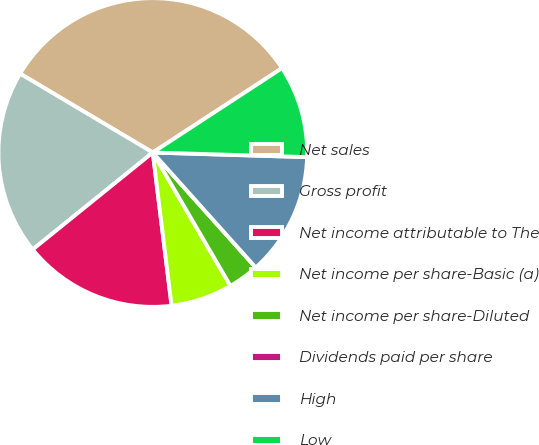Convert chart. <chart><loc_0><loc_0><loc_500><loc_500><pie_chart><fcel>Net sales<fcel>Gross profit<fcel>Net income attributable to The<fcel>Net income per share-Basic (a)<fcel>Net income per share-Diluted<fcel>Dividends paid per share<fcel>High<fcel>Low<nl><fcel>32.26%<fcel>19.35%<fcel>16.13%<fcel>6.45%<fcel>3.23%<fcel>0.0%<fcel>12.9%<fcel>9.68%<nl></chart> 